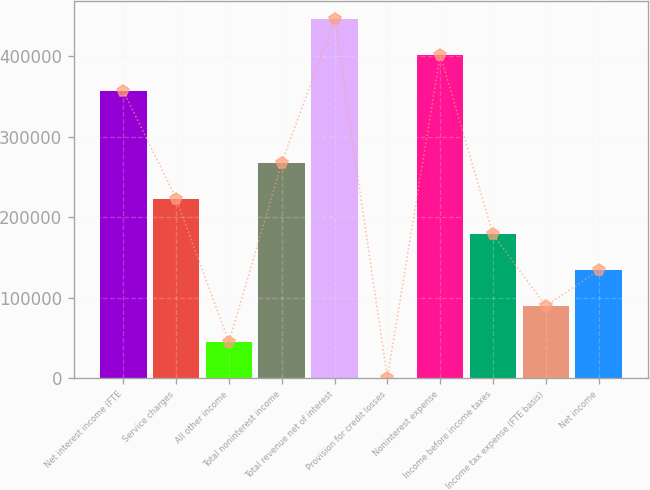Convert chart to OTSL. <chart><loc_0><loc_0><loc_500><loc_500><bar_chart><fcel>Net interest income (FTE<fcel>Service charges<fcel>All other income<fcel>Total noninterest income<fcel>Total revenue net of interest<fcel>Provision for credit losses<fcel>Noninterest expense<fcel>Income before income taxes<fcel>Income tax expense (FTE basis)<fcel>Net income<nl><fcel>356772<fcel>223048<fcel>44747.9<fcel>267622<fcel>445922<fcel>173<fcel>401347<fcel>178473<fcel>89322.8<fcel>133898<nl></chart> 